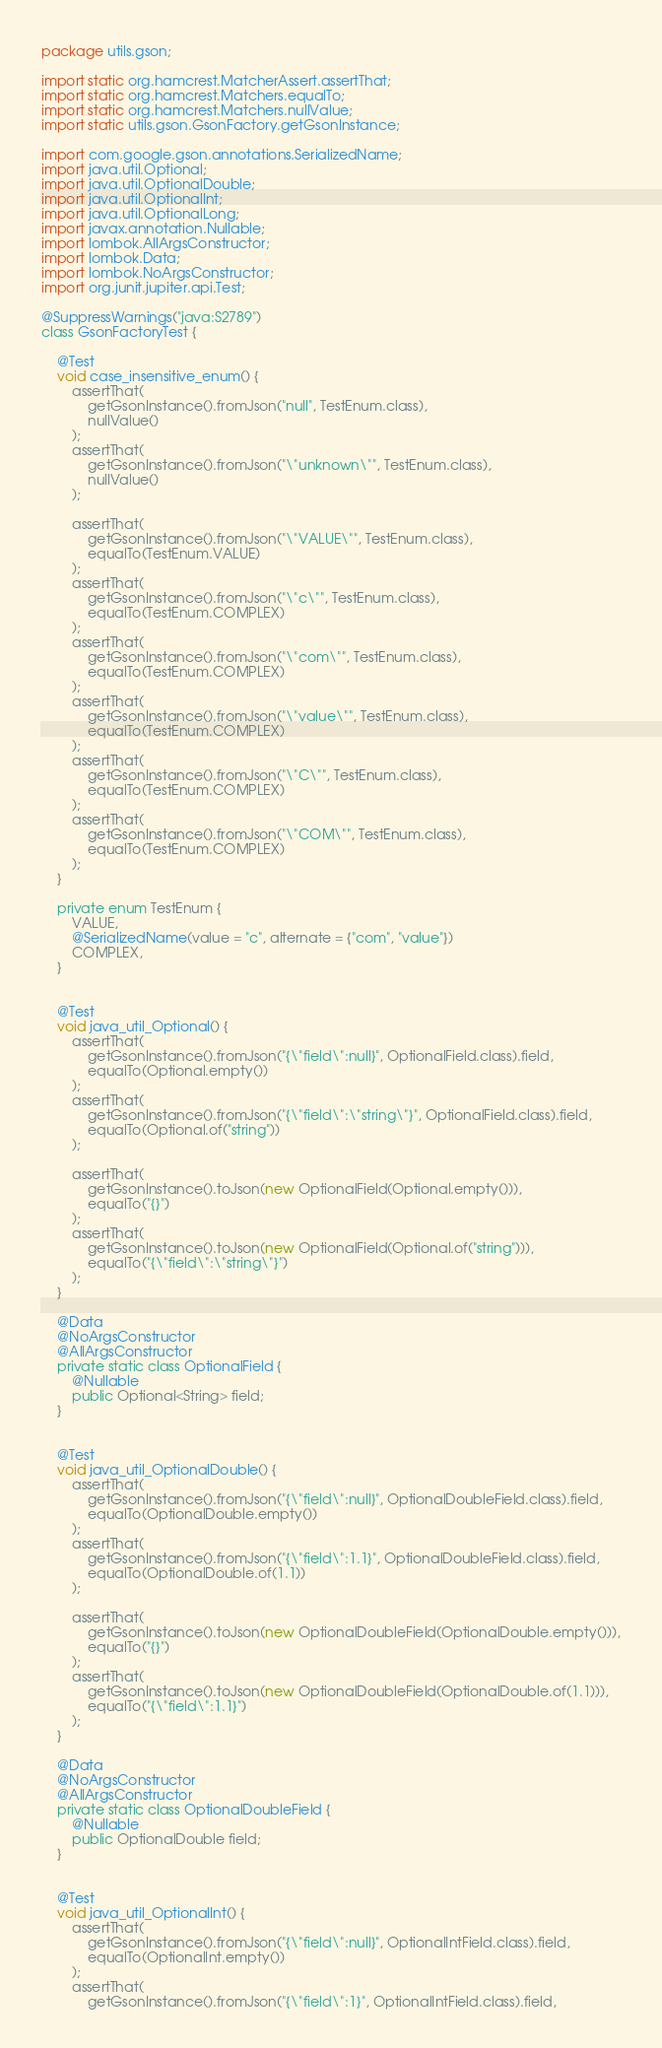<code> <loc_0><loc_0><loc_500><loc_500><_Java_>package utils.gson;

import static org.hamcrest.MatcherAssert.assertThat;
import static org.hamcrest.Matchers.equalTo;
import static org.hamcrest.Matchers.nullValue;
import static utils.gson.GsonFactory.getGsonInstance;

import com.google.gson.annotations.SerializedName;
import java.util.Optional;
import java.util.OptionalDouble;
import java.util.OptionalInt;
import java.util.OptionalLong;
import javax.annotation.Nullable;
import lombok.AllArgsConstructor;
import lombok.Data;
import lombok.NoArgsConstructor;
import org.junit.jupiter.api.Test;

@SuppressWarnings("java:S2789")
class GsonFactoryTest {

    @Test
    void case_insensitive_enum() {
        assertThat(
            getGsonInstance().fromJson("null", TestEnum.class),
            nullValue()
        );
        assertThat(
            getGsonInstance().fromJson("\"unknown\"", TestEnum.class),
            nullValue()
        );

        assertThat(
            getGsonInstance().fromJson("\"VALUE\"", TestEnum.class),
            equalTo(TestEnum.VALUE)
        );
        assertThat(
            getGsonInstance().fromJson("\"c\"", TestEnum.class),
            equalTo(TestEnum.COMPLEX)
        );
        assertThat(
            getGsonInstance().fromJson("\"com\"", TestEnum.class),
            equalTo(TestEnum.COMPLEX)
        );
        assertThat(
            getGsonInstance().fromJson("\"value\"", TestEnum.class),
            equalTo(TestEnum.COMPLEX)
        );
        assertThat(
            getGsonInstance().fromJson("\"C\"", TestEnum.class),
            equalTo(TestEnum.COMPLEX)
        );
        assertThat(
            getGsonInstance().fromJson("\"COM\"", TestEnum.class),
            equalTo(TestEnum.COMPLEX)
        );
    }

    private enum TestEnum {
        VALUE,
        @SerializedName(value = "c", alternate = {"com", "value"})
        COMPLEX,
    }


    @Test
    void java_util_Optional() {
        assertThat(
            getGsonInstance().fromJson("{\"field\":null}", OptionalField.class).field,
            equalTo(Optional.empty())
        );
        assertThat(
            getGsonInstance().fromJson("{\"field\":\"string\"}", OptionalField.class).field,
            equalTo(Optional.of("string"))
        );

        assertThat(
            getGsonInstance().toJson(new OptionalField(Optional.empty())),
            equalTo("{}")
        );
        assertThat(
            getGsonInstance().toJson(new OptionalField(Optional.of("string"))),
            equalTo("{\"field\":\"string\"}")
        );
    }

    @Data
    @NoArgsConstructor
    @AllArgsConstructor
    private static class OptionalField {
        @Nullable
        public Optional<String> field;
    }


    @Test
    void java_util_OptionalDouble() {
        assertThat(
            getGsonInstance().fromJson("{\"field\":null}", OptionalDoubleField.class).field,
            equalTo(OptionalDouble.empty())
        );
        assertThat(
            getGsonInstance().fromJson("{\"field\":1.1}", OptionalDoubleField.class).field,
            equalTo(OptionalDouble.of(1.1))
        );

        assertThat(
            getGsonInstance().toJson(new OptionalDoubleField(OptionalDouble.empty())),
            equalTo("{}")
        );
        assertThat(
            getGsonInstance().toJson(new OptionalDoubleField(OptionalDouble.of(1.1))),
            equalTo("{\"field\":1.1}")
        );
    }

    @Data
    @NoArgsConstructor
    @AllArgsConstructor
    private static class OptionalDoubleField {
        @Nullable
        public OptionalDouble field;
    }


    @Test
    void java_util_OptionalInt() {
        assertThat(
            getGsonInstance().fromJson("{\"field\":null}", OptionalIntField.class).field,
            equalTo(OptionalInt.empty())
        );
        assertThat(
            getGsonInstance().fromJson("{\"field\":1}", OptionalIntField.class).field,</code> 